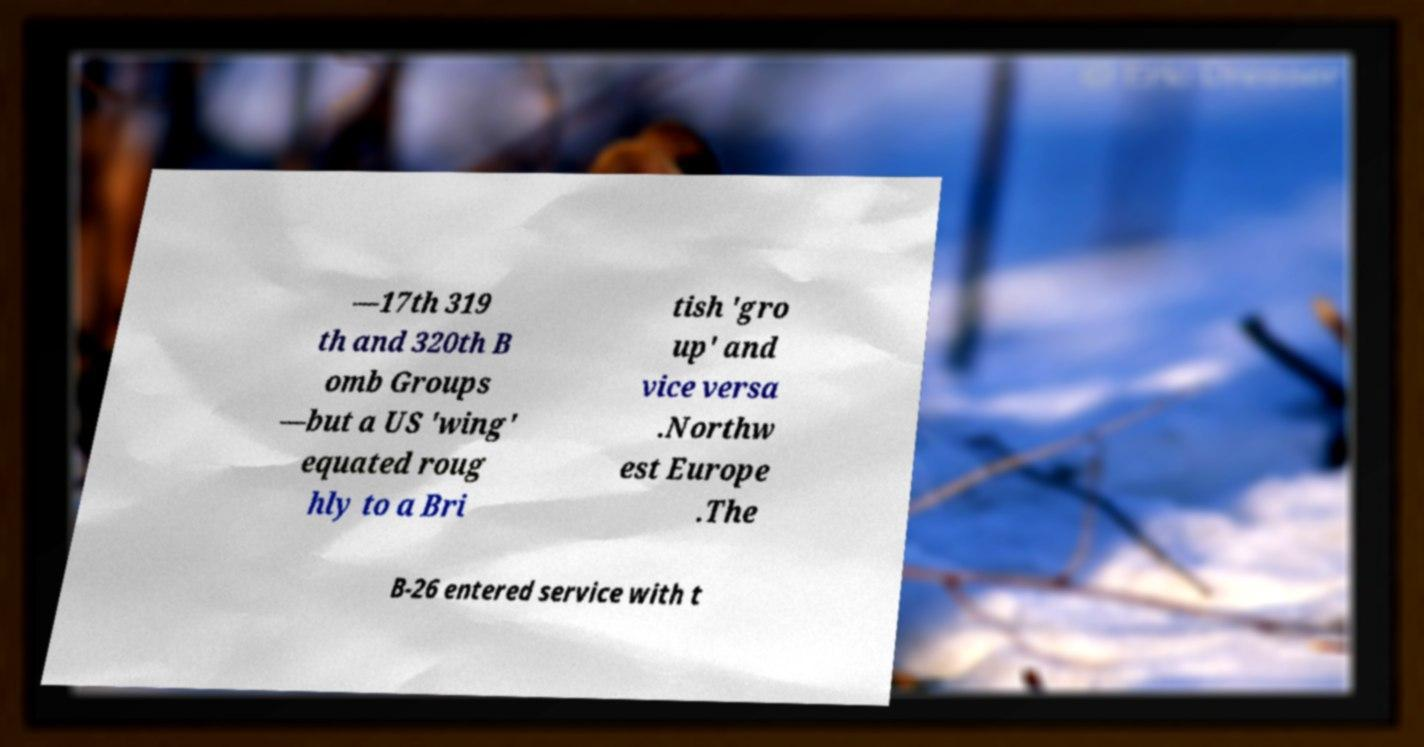For documentation purposes, I need the text within this image transcribed. Could you provide that? —17th 319 th and 320th B omb Groups —but a US 'wing' equated roug hly to a Bri tish 'gro up' and vice versa .Northw est Europe .The B-26 entered service with t 